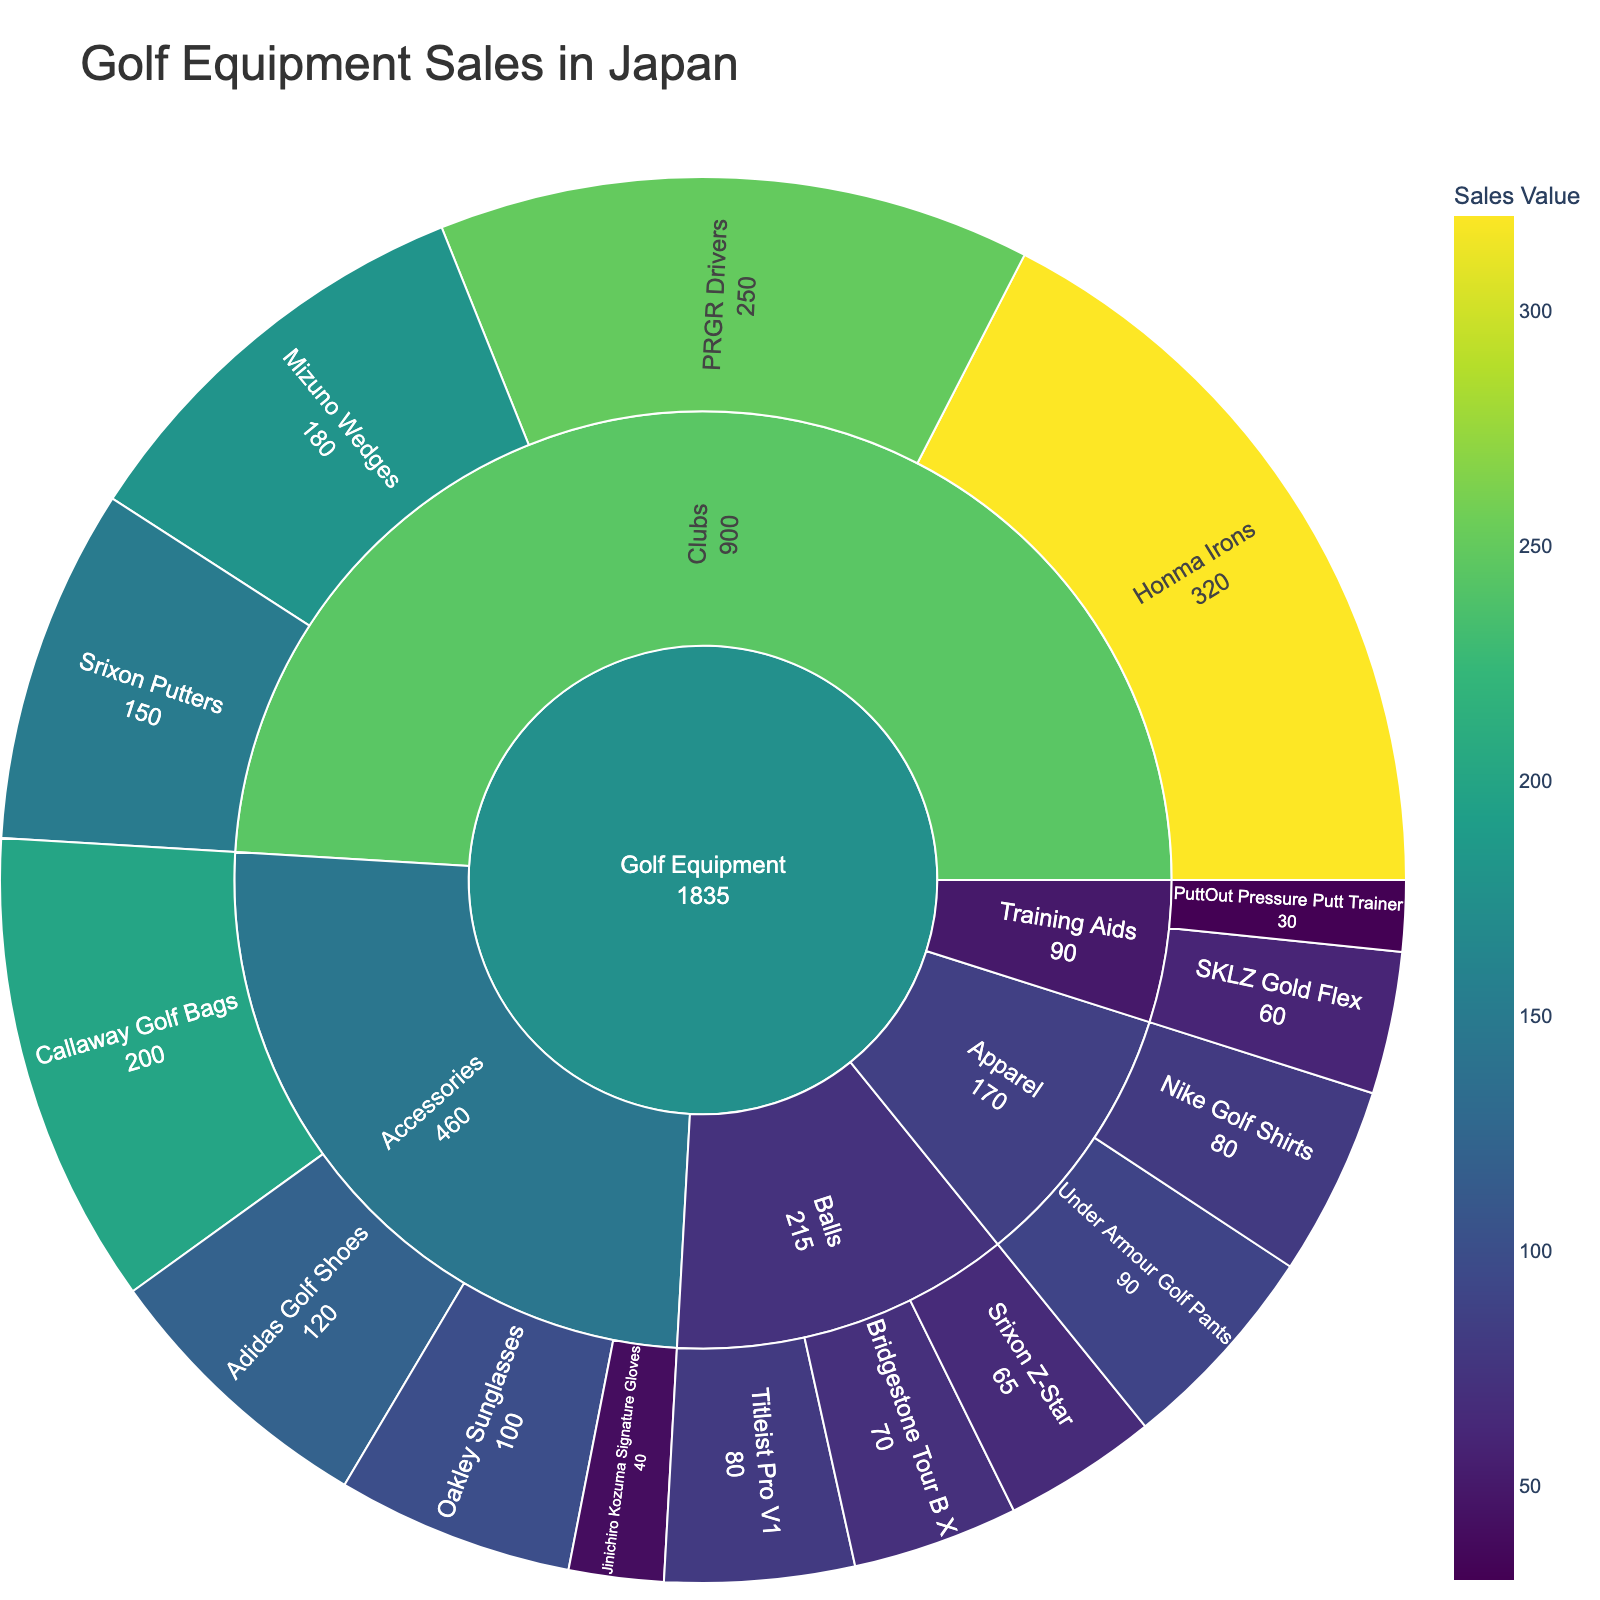what is the title of the figure? The title is usually found at the top of the plot and provides a brief description of what the figure represents. In this case, it is "Golf Equipment Sales in Japan" as specified in the plotting code.
Answer: Golf Equipment Sales in Japan Which brand of clubs has the highest sales value? To answer this question, look at the Clubs subcategory in the Sunburst Plot and identify the product with the highest numerical value labeled. In this case, "Honma Irons" with a sales value of ¥320K is the highest among the clubs.
Answer: Honma Irons What is the total sales value for golf balls? Sum up the sales values labeled for all the products under the Balls subcategory: Titleist Pro V1 (¥80K), Bridgestone Tour B X (¥70K), and Srixon Z-Star (¥65K). Adding these together gives ¥215K.
Answer: ¥215K Which product has the lowest sales value under the Accessories subcategory? Look at the Accessories subcategory and identify the product with the smallest numerical value labeled. "Jinichiro Kozuma Signature Gloves" has the lowest value with ¥40K.
Answer: Jinichiro Kozuma Signature Gloves How do the sales values of Training Aids compare to Apparel? To answer this, compare the total values of all products under Training Aids and Apparel. The total for Training Aids is SKLZ Gold Flex (¥60K) + PuttOut Pressure Putt Trainer (¥30K) = ¥90K. For Apparel, it is Nike Golf Shirts (¥80K) + Under Armour Golf Pants (¥90K) = ¥170K. So, Apparel has a higher total sales value.
Answer: Apparel has higher total sales Which category has the highest total sales value? Sum up the sales values for each category: Clubs, Balls, Accessories, Training Aids, and Apparel. Clubs total to ¥900K, Balls to ¥215K, Accessories to ¥460K, Training Aids to ¥90K, and Apparel to ¥170K. Clubs have the highest total sales value.
Answer: Clubs What are the sales values of products under Clubs category? The sales values for products under the Clubs category can be found by looking at the labeled values: PRGR Drivers (¥250K), Honma Irons (¥320K), Mizuno Wedges (¥180K), and Srixon Putters (¥150K).
Answer: ¥250K, ¥320K, ¥180K, ¥150K What is the difference in sales value between Callaway Golf Bags and Adidas Golf Shoes? Subtract the sales value of Adidas Golf Shoes (¥120K) from the sales value of Callaway Golf Bags (¥200K): 200K - 120K = 80K.
Answer: ¥80K Which product has the highest sales value in the Training Aids subcategory? Identify the product with the highest numerical value within Training Aids. "SKLZ Gold Flex" has the highest value in Training Aids, which is ¥60K.
Answer: SKLZ Gold Flex 